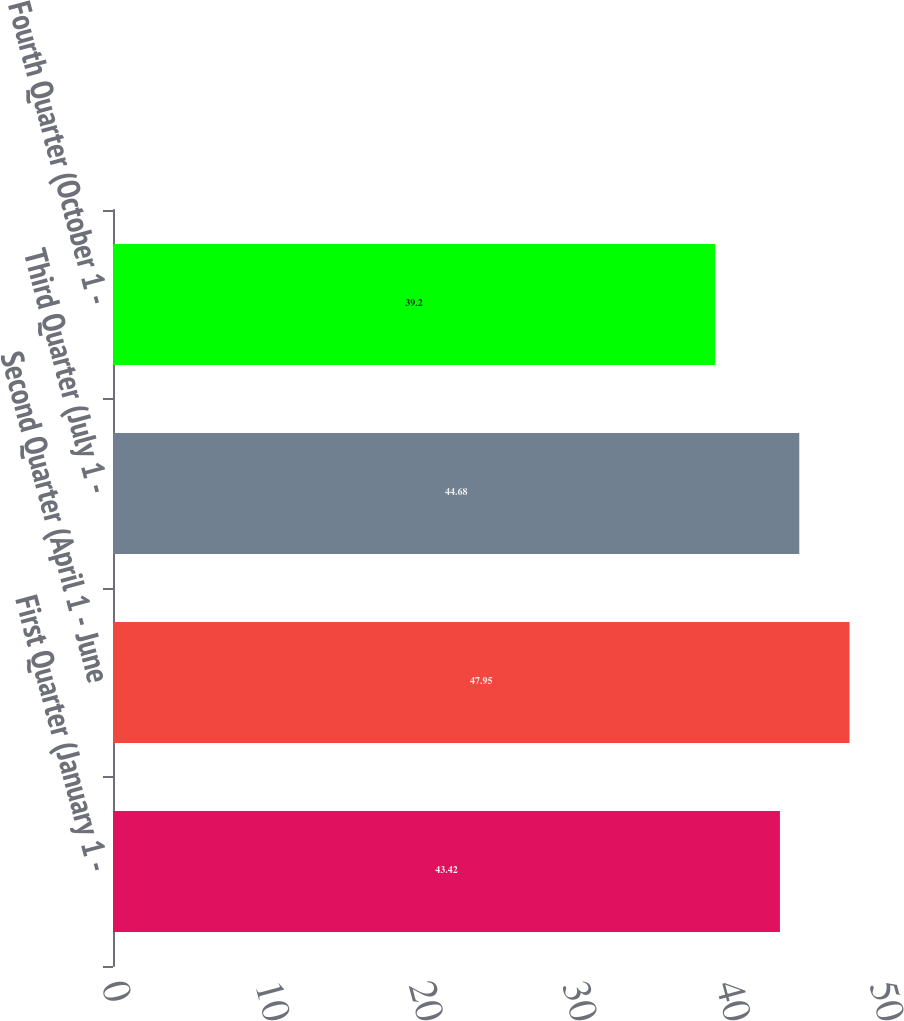<chart> <loc_0><loc_0><loc_500><loc_500><bar_chart><fcel>First Quarter (January 1 -<fcel>Second Quarter (April 1 - June<fcel>Third Quarter (July 1 -<fcel>Fourth Quarter (October 1 -<nl><fcel>43.42<fcel>47.95<fcel>44.68<fcel>39.2<nl></chart> 